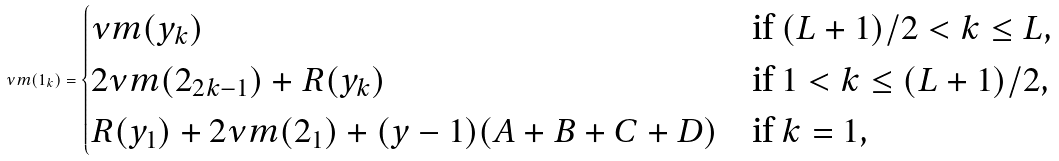<formula> <loc_0><loc_0><loc_500><loc_500>\nu m ( 1 _ { k } ) = \begin{cases} \nu m ( y _ { k } ) & \text {if $(L+1)/2 < k \leq L$,} \\ 2 \nu m ( 2 _ { 2 k - 1 } ) + R ( y _ { k } ) & \text {if $1 < k \leq (L+1)/2$,} \\ R ( y _ { 1 } ) + 2 \nu m ( 2 _ { 1 } ) + ( y - 1 ) ( A + B + C + D ) & \text {if $k=1$,} \end{cases}</formula> 